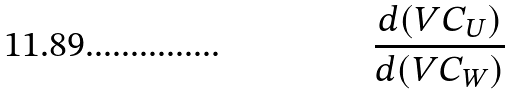<formula> <loc_0><loc_0><loc_500><loc_500>\frac { d ( V C _ { U } ) } { d ( V C _ { W } ) }</formula> 